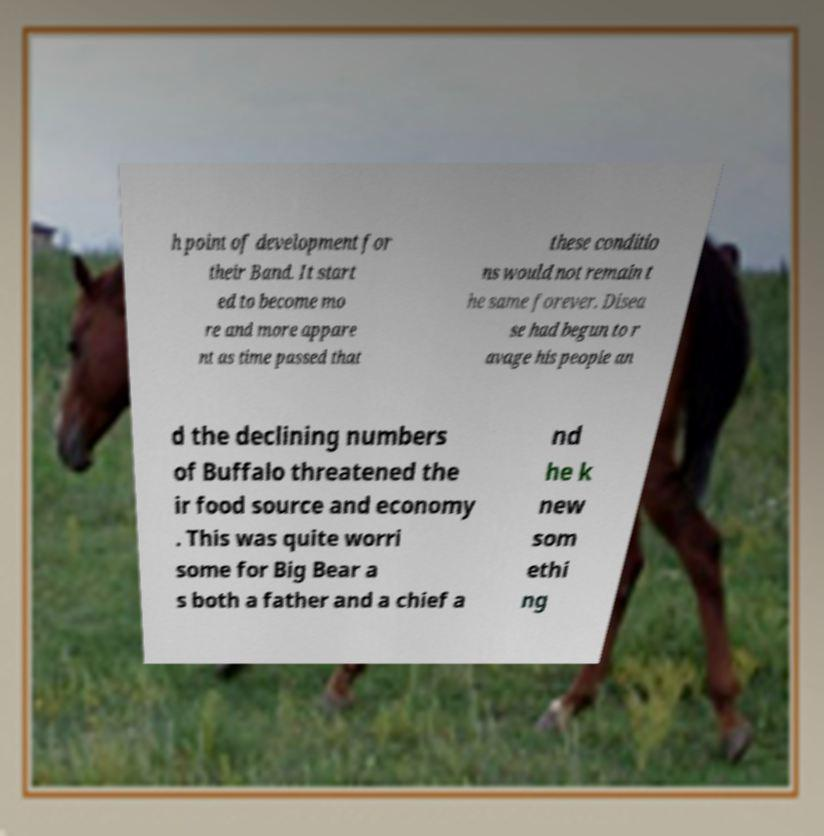Could you extract and type out the text from this image? h point of development for their Band. It start ed to become mo re and more appare nt as time passed that these conditio ns would not remain t he same forever. Disea se had begun to r avage his people an d the declining numbers of Buffalo threatened the ir food source and economy . This was quite worri some for Big Bear a s both a father and a chief a nd he k new som ethi ng 